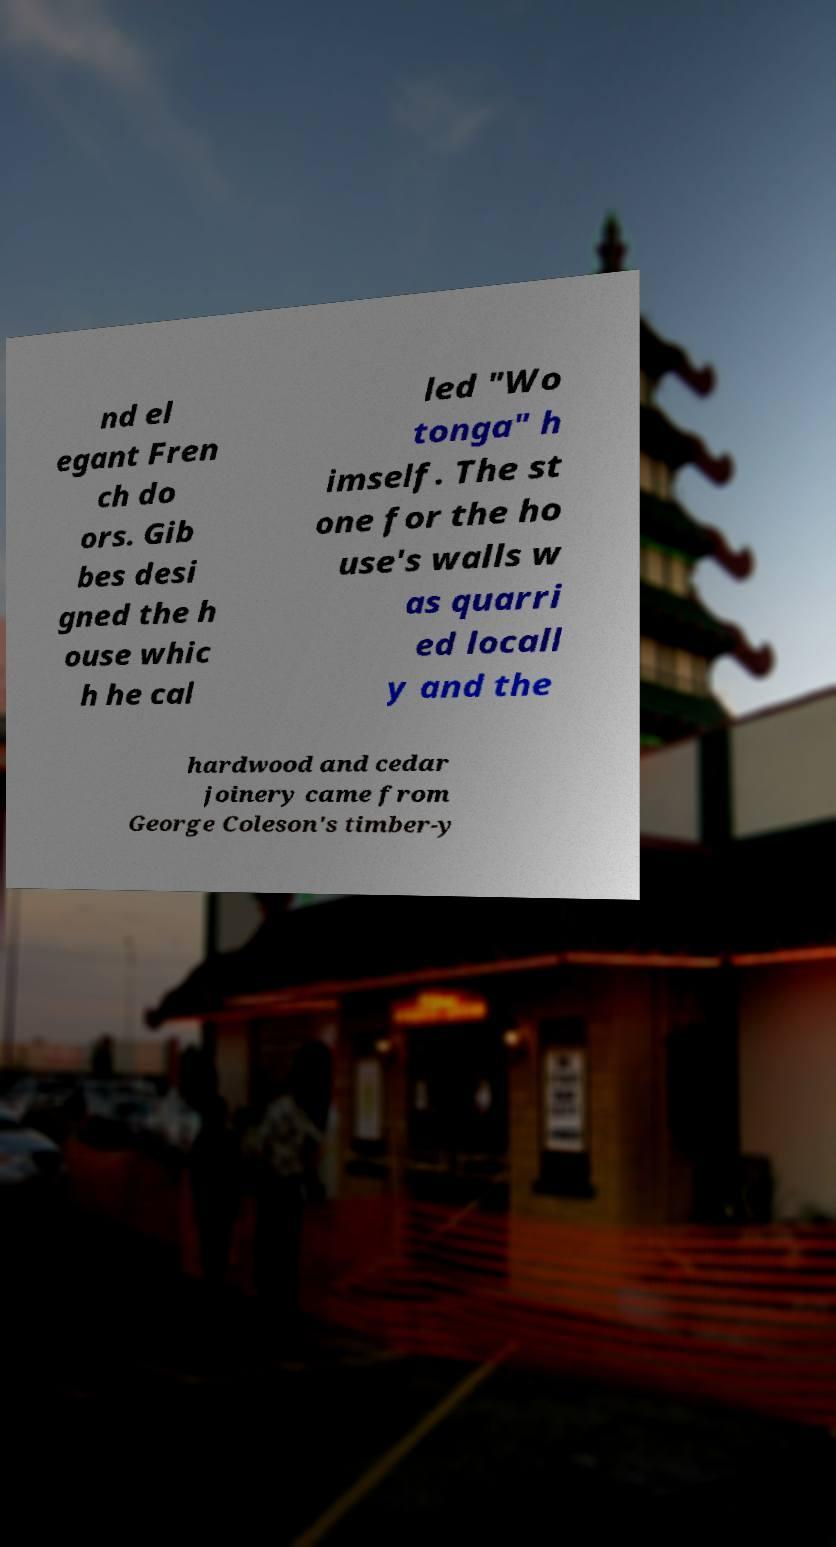Please read and relay the text visible in this image. What does it say? nd el egant Fren ch do ors. Gib bes desi gned the h ouse whic h he cal led "Wo tonga" h imself. The st one for the ho use's walls w as quarri ed locall y and the hardwood and cedar joinery came from George Coleson's timber-y 